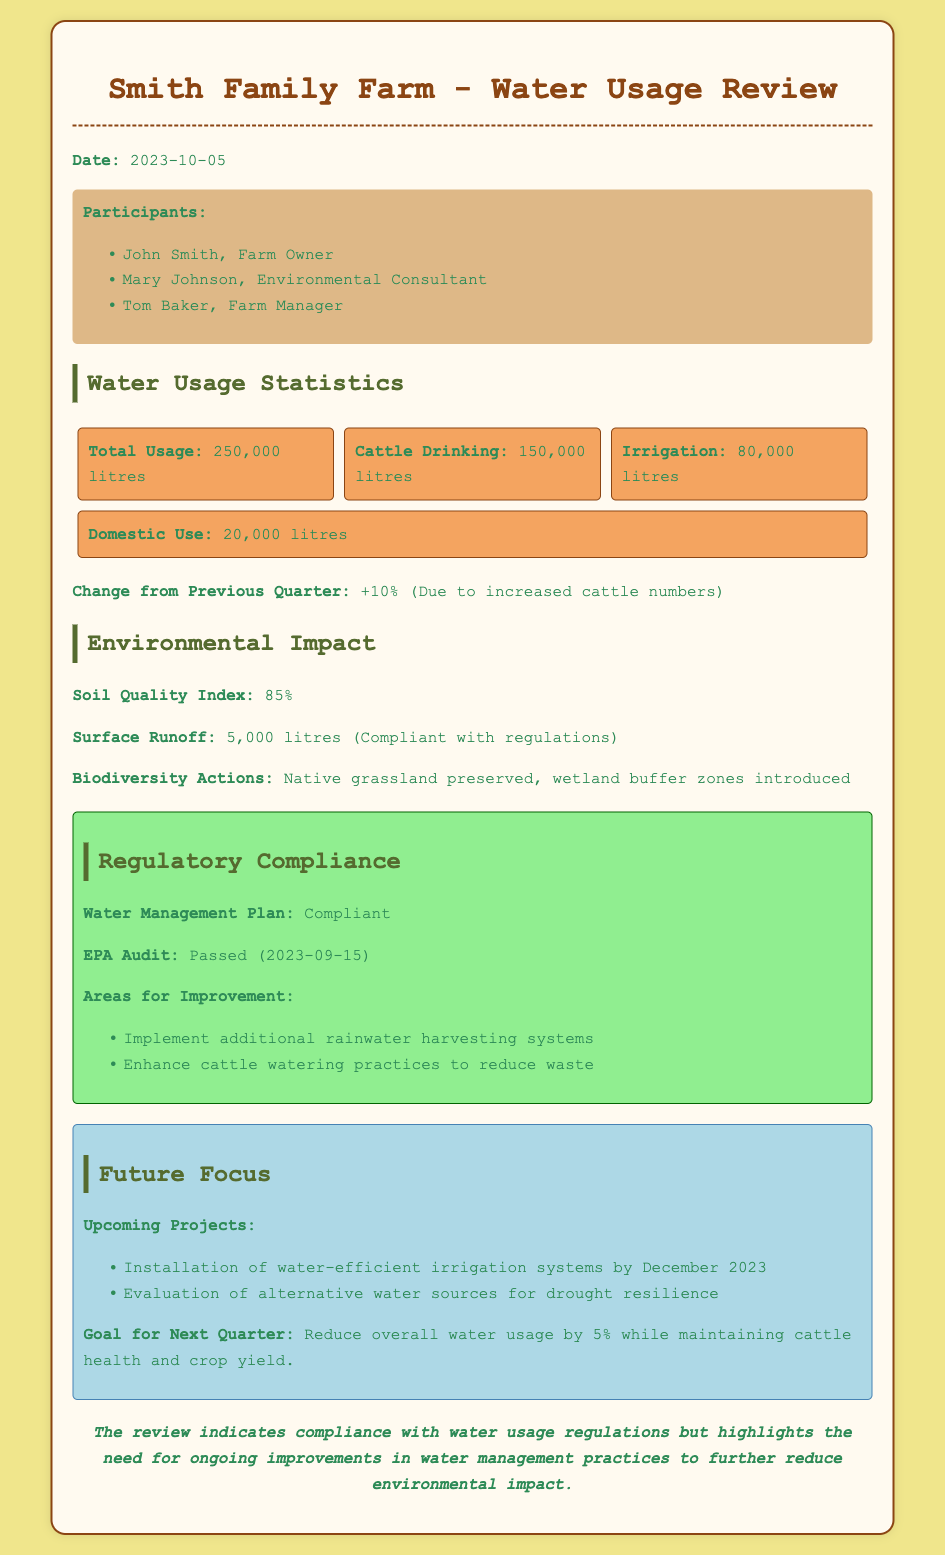what is the date of the meeting? The date of the meeting is mentioned in the document as 2023-10-05.
Answer: 2023-10-05 who is the farm owner? The farm owner is listed as John Smith in the participants section.
Answer: John Smith what was the total water usage this quarter? The total water usage is provided in the water usage statistics as 250,000 litres.
Answer: 250,000 litres how much water was used for cattle drinking? The document states that cattle drinking accounted for 150,000 litres of water usage.
Answer: 150,000 litres what is the Soil Quality Index percentage? The Soil Quality Index is reported as 85% in the environmental impact section.
Answer: 85% how did the total water usage change from the previous quarter? The document lists that the change from the previous quarter is +10%.
Answer: +10% which audit did the farm pass? The farm passed the EPA Audit mentioned in the regulatory compliance section.
Answer: EPA Audit what is one area for improvement mentioned? The document lists implementing additional rainwater harvesting systems as an area for improvement.
Answer: Implement additional rainwater harvesting systems what is the goal for the next quarter? The goal for the next quarter is to reduce overall water usage by 5%.
Answer: Reduce overall water usage by 5% 